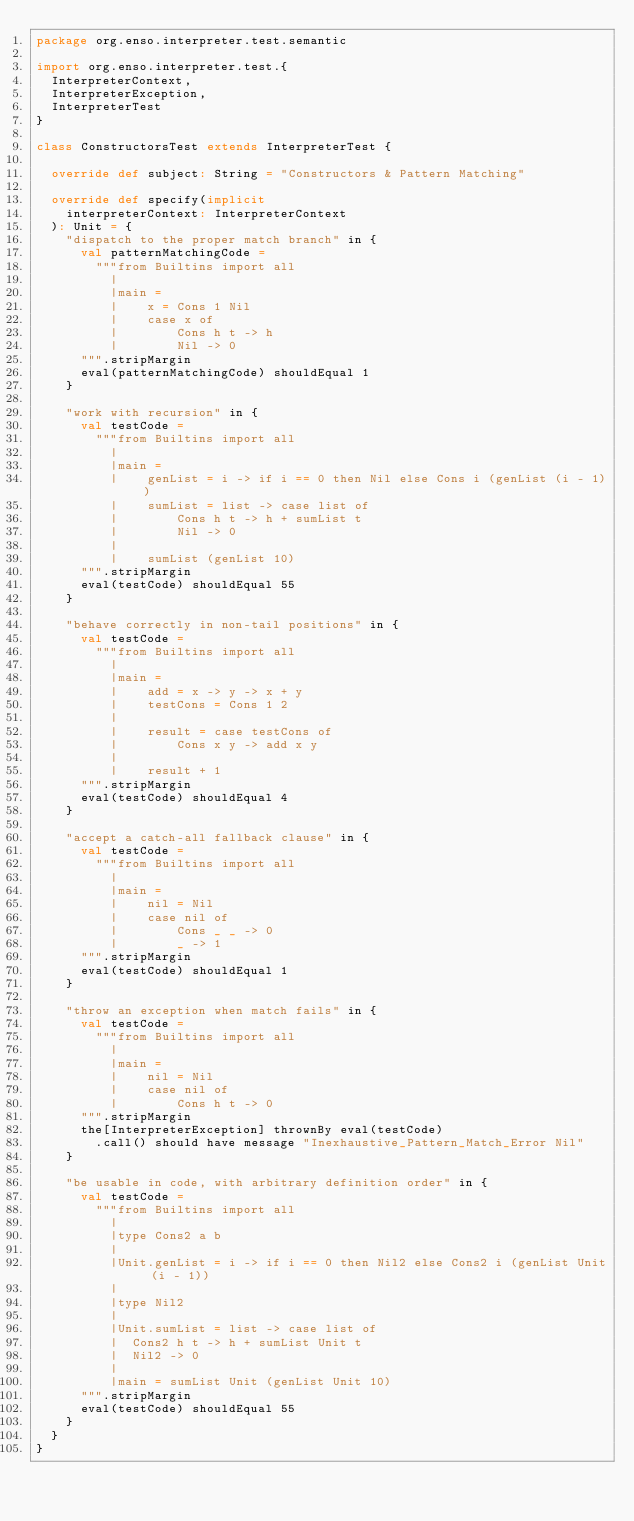<code> <loc_0><loc_0><loc_500><loc_500><_Scala_>package org.enso.interpreter.test.semantic

import org.enso.interpreter.test.{
  InterpreterContext,
  InterpreterException,
  InterpreterTest
}

class ConstructorsTest extends InterpreterTest {

  override def subject: String = "Constructors & Pattern Matching"

  override def specify(implicit
    interpreterContext: InterpreterContext
  ): Unit = {
    "dispatch to the proper match branch" in {
      val patternMatchingCode =
        """from Builtins import all
          |
          |main =
          |    x = Cons 1 Nil
          |    case x of
          |        Cons h t -> h
          |        Nil -> 0
      """.stripMargin
      eval(patternMatchingCode) shouldEqual 1
    }

    "work with recursion" in {
      val testCode =
        """from Builtins import all
          |
          |main =
          |    genList = i -> if i == 0 then Nil else Cons i (genList (i - 1))
          |    sumList = list -> case list of
          |        Cons h t -> h + sumList t
          |        Nil -> 0
          |
          |    sumList (genList 10)
      """.stripMargin
      eval(testCode) shouldEqual 55
    }

    "behave correctly in non-tail positions" in {
      val testCode =
        """from Builtins import all
          |
          |main =
          |    add = x -> y -> x + y
          |    testCons = Cons 1 2
          |
          |    result = case testCons of
          |        Cons x y -> add x y
          |
          |    result + 1
      """.stripMargin
      eval(testCode) shouldEqual 4
    }

    "accept a catch-all fallback clause" in {
      val testCode =
        """from Builtins import all
          |
          |main =
          |    nil = Nil
          |    case nil of
          |        Cons _ _ -> 0
          |        _ -> 1
      """.stripMargin
      eval(testCode) shouldEqual 1
    }

    "throw an exception when match fails" in {
      val testCode =
        """from Builtins import all
          |
          |main =
          |    nil = Nil
          |    case nil of
          |        Cons h t -> 0
      """.stripMargin
      the[InterpreterException] thrownBy eval(testCode)
        .call() should have message "Inexhaustive_Pattern_Match_Error Nil"
    }

    "be usable in code, with arbitrary definition order" in {
      val testCode =
        """from Builtins import all
          |
          |type Cons2 a b
          |
          |Unit.genList = i -> if i == 0 then Nil2 else Cons2 i (genList Unit (i - 1))
          |
          |type Nil2
          |
          |Unit.sumList = list -> case list of
          |  Cons2 h t -> h + sumList Unit t
          |  Nil2 -> 0
          |
          |main = sumList Unit (genList Unit 10)
      """.stripMargin
      eval(testCode) shouldEqual 55
    }
  }
}
</code> 